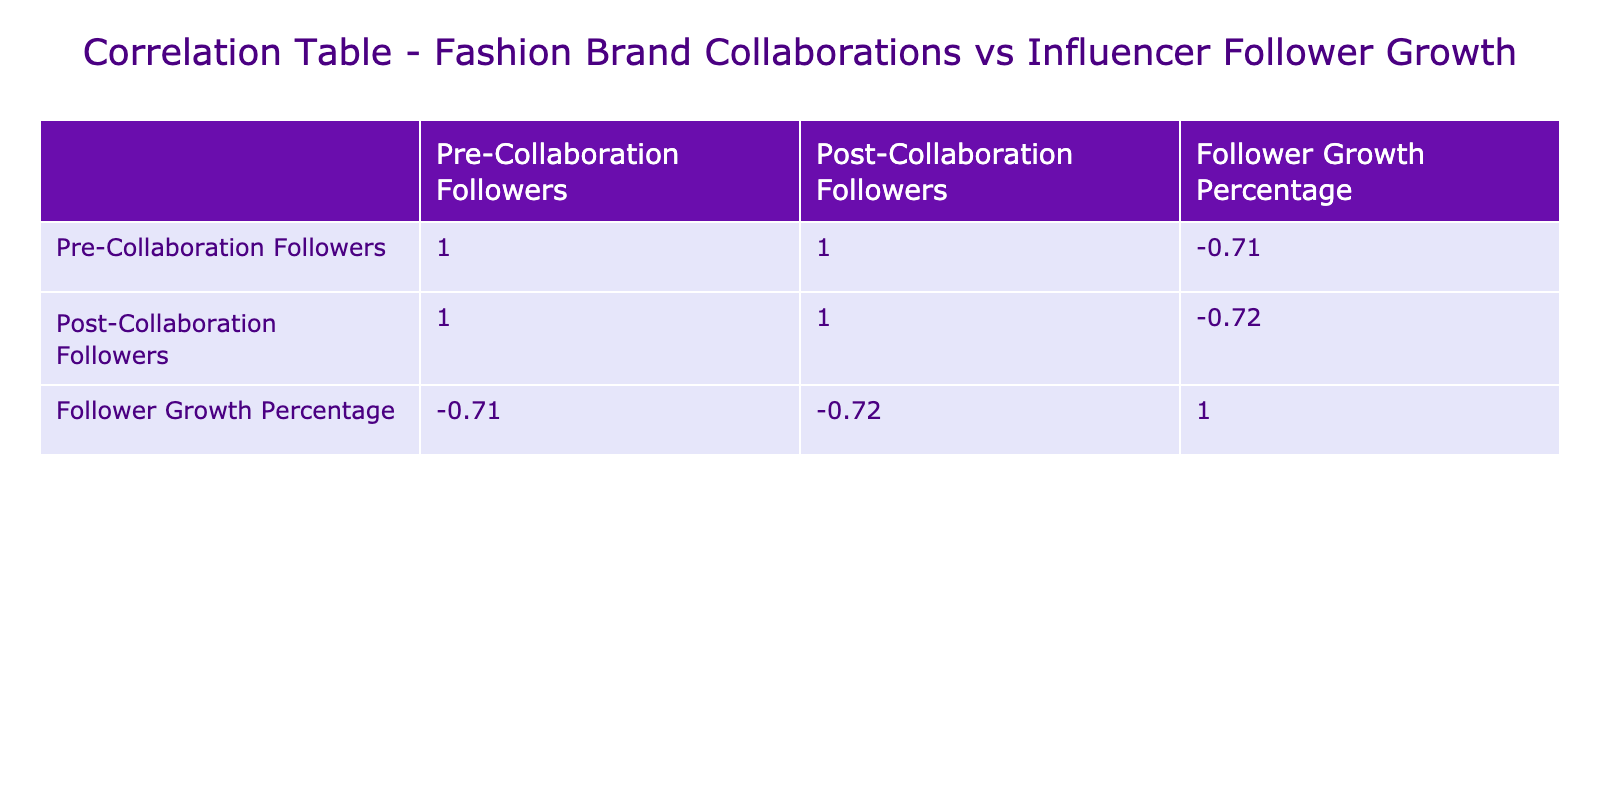What is the highest follower growth percentage among the collaborations? The highest follower growth percentage is shown under the collaboration "Gucci x Dapper Dan," which has a growth of 33.33%.
Answer: 33.33 Which influencer experienced the lowest follower growth percentage after their collaboration? Looking at the follower growth percentages in the table, "Balenciaga x Kim Kardashian" shows the lowest at 5.00%.
Answer: 5.00 What is the average follower growth percentage across all collaborations? To find the average, sum all the follower growth percentages: (33.33 + 5.00 + 8.57 + 20.00 + 14.29 + 30.00 + 20.00 + 13.33 + 6.25 + 33.33) =  250.00, then divide by the number of collaborations, which is 10. Thus, 250.00 / 10 = 25.00 is the average growth percentage.
Answer: 25.00 Is there a correlation between pre-collaboration followers and follower growth percentage? To determine this, we would need to analyze the correlation value in the table; however, without exact numeric values, we can deduce that the presence of high pre-collaboration follower counts does not always equate to high growth percentages, as presented in the data but cannot assume a definitive correlation. Therefore, the answer to whether a correlation exists would be 'no'.
Answer: No Which influencer showed the largest increase in followers after their brand collaboration? Identifying the post and pre-collaboration followers: "Dapper Dan" increased from 45000 to 60000, resulting in an increase of 15000 followers. Comparatively, "Kim Kardashian" gained 1000000 followers (from 20000000 to 21000000). Therefore, Kim Kardashian exhibited the largest increase.
Answer: Kim Kardashian 